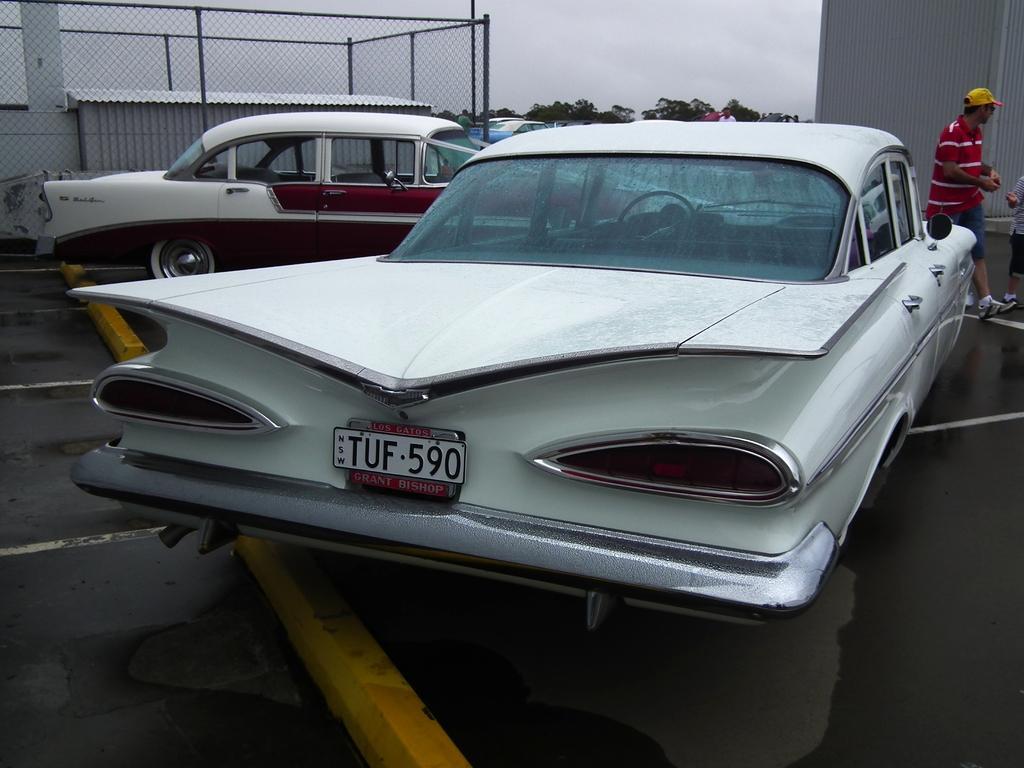How would you summarize this image in a sentence or two? In the foreground of the picture there is a car. On the right, there are two people walking. On the left there are car, fencing and small construction. At the center of the background there are cars, trees and people. Sky is cloudy. 